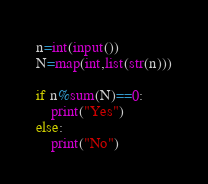<code> <loc_0><loc_0><loc_500><loc_500><_Python_>n=int(input())
N=map(int,list(str(n)))

if n%sum(N)==0:
    print("Yes")
else:
    print("No")

</code> 